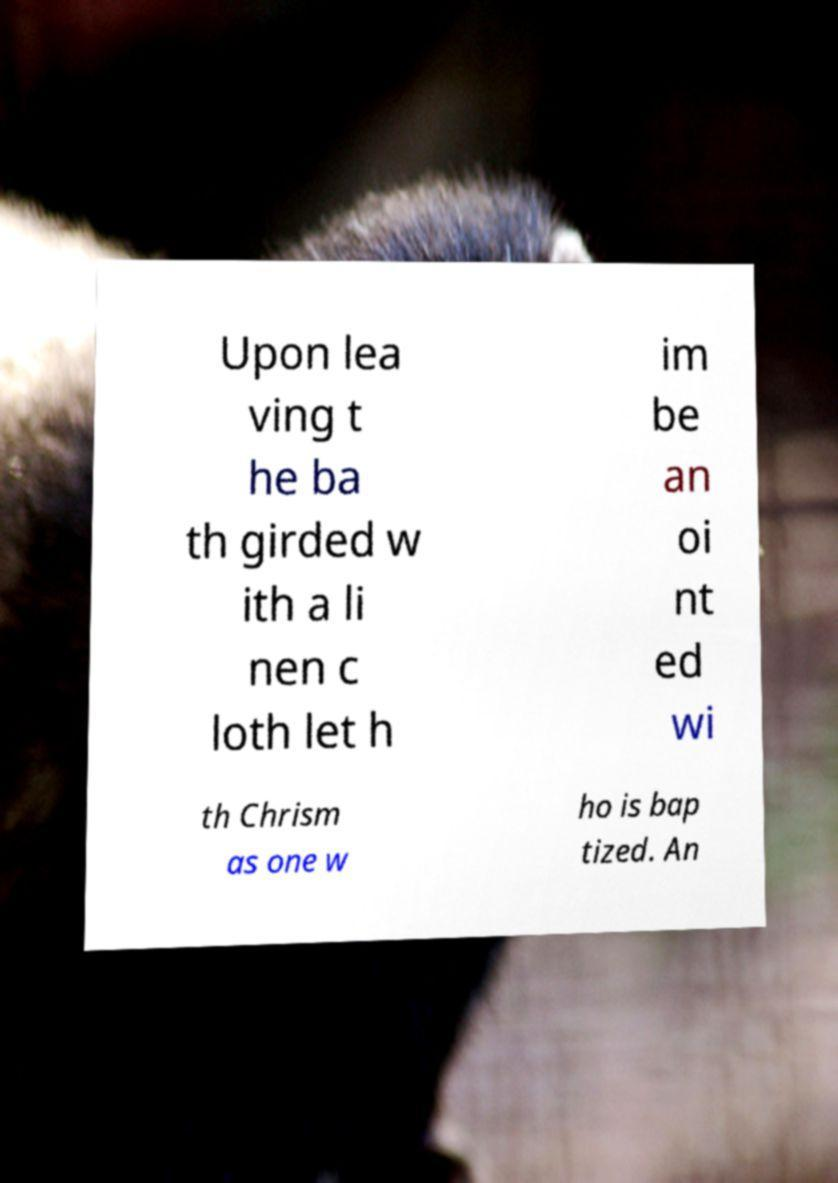Can you read and provide the text displayed in the image?This photo seems to have some interesting text. Can you extract and type it out for me? Upon lea ving t he ba th girded w ith a li nen c loth let h im be an oi nt ed wi th Chrism as one w ho is bap tized. An 